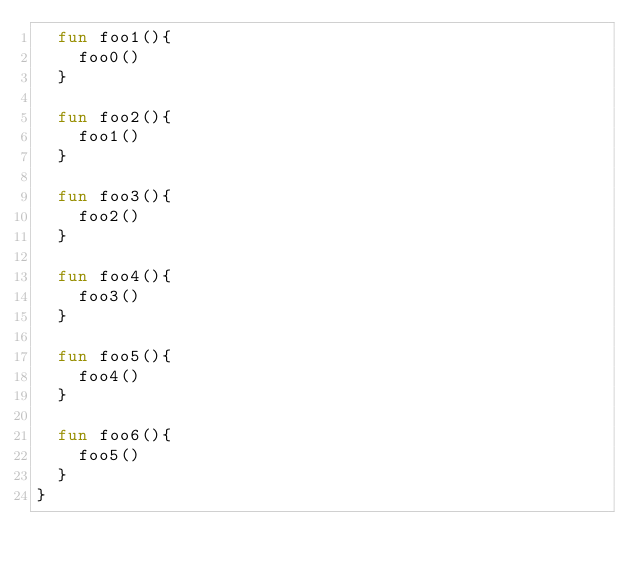Convert code to text. <code><loc_0><loc_0><loc_500><loc_500><_Kotlin_>  fun foo1(){
    foo0()
  }

  fun foo2(){
    foo1()
  }

  fun foo3(){
    foo2()
  }

  fun foo4(){
    foo3()
  }

  fun foo5(){
    foo4()
  }

  fun foo6(){
    foo5()
  }
}</code> 